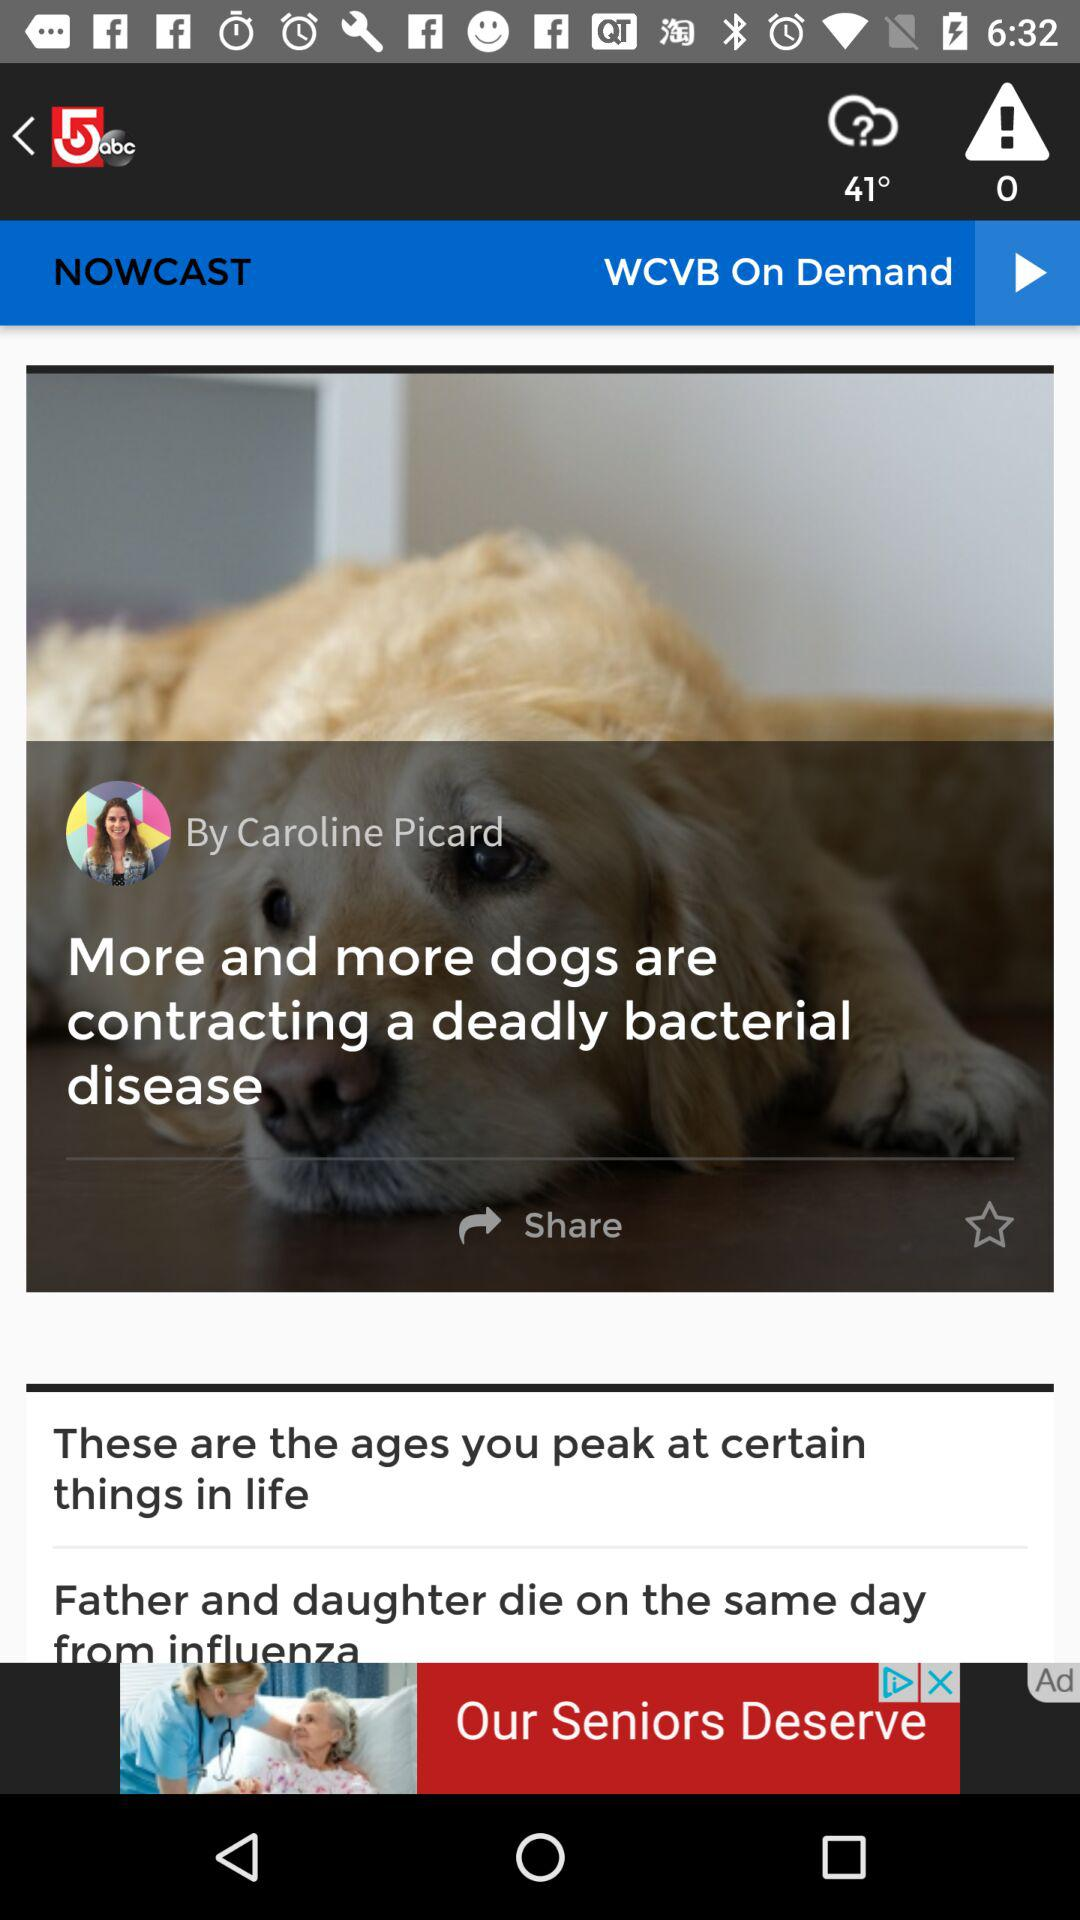What is the author's name? The author's name is Caroline Picard. 